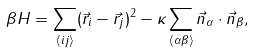<formula> <loc_0><loc_0><loc_500><loc_500>\beta H = \sum _ { \langle i j \rangle } ( \vec { r } _ { i } - \vec { r } _ { j } ) ^ { 2 } - \kappa \sum _ { \langle \alpha \beta \rangle } \vec { n } _ { \alpha } \cdot \vec { n } _ { \beta } ,</formula> 